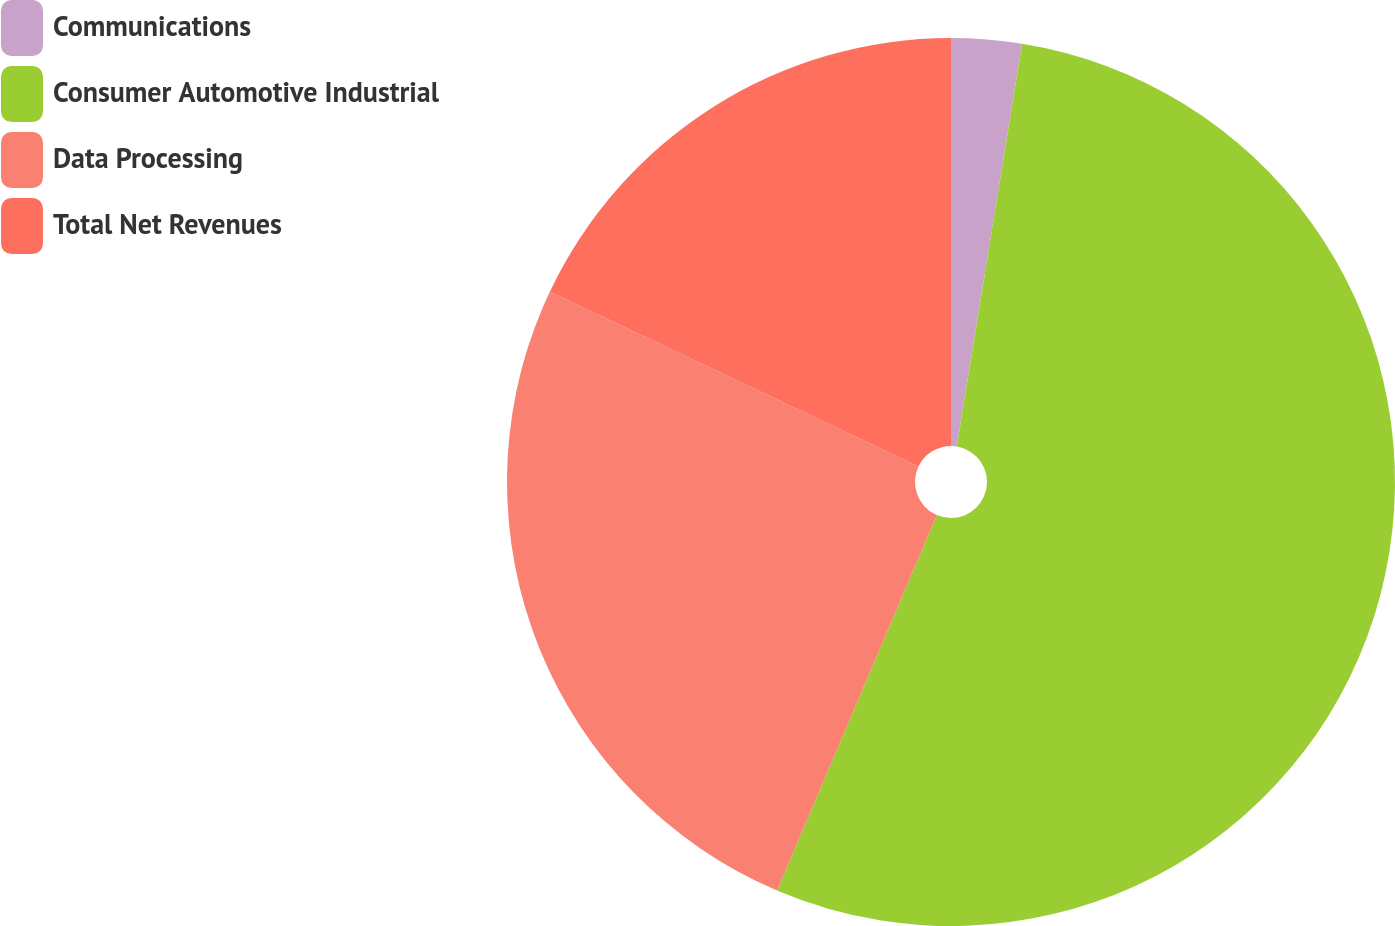<chart> <loc_0><loc_0><loc_500><loc_500><pie_chart><fcel>Communications<fcel>Consumer Automotive Industrial<fcel>Data Processing<fcel>Total Net Revenues<nl><fcel>2.56%<fcel>53.85%<fcel>25.64%<fcel>17.95%<nl></chart> 